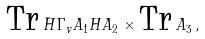Convert formula to latex. <formula><loc_0><loc_0><loc_500><loc_500>\text {Tr} \, \bar { H } \Gamma _ { v } A _ { 1 } H A _ { 2 } \times \text {Tr} \, A _ { 3 } \, ,</formula> 